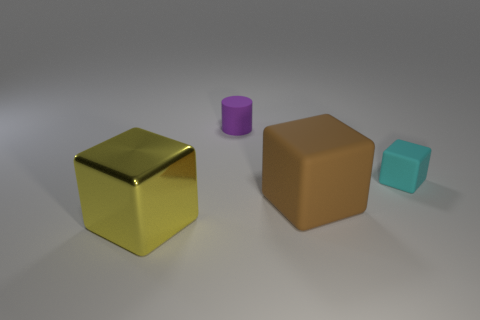What size is the cyan thing that is the same shape as the large brown rubber thing?
Ensure brevity in your answer.  Small. Are there an equal number of tiny cyan blocks in front of the large brown matte object and things that are in front of the purple thing?
Give a very brief answer. No. There is a block to the left of the purple thing; what is its size?
Provide a succinct answer. Large. Is the small cylinder the same color as the tiny matte cube?
Your answer should be compact. No. Are there any other things that are the same shape as the big yellow object?
Give a very brief answer. Yes. Are there an equal number of large yellow shiny things to the right of the big yellow metal block and tiny yellow rubber things?
Keep it short and to the point. Yes. There is a big yellow cube; are there any tiny cyan cubes to the right of it?
Provide a short and direct response. Yes. Does the large yellow thing have the same shape as the rubber object in front of the cyan matte thing?
Your answer should be compact. Yes. There is another big block that is made of the same material as the cyan cube; what color is it?
Make the answer very short. Brown. What color is the big rubber block?
Provide a short and direct response. Brown. 